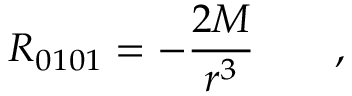Convert formula to latex. <formula><loc_0><loc_0><loc_500><loc_500>R _ { 0 1 0 1 } = - \frac { 2 M } { r ^ { 3 } } \quad ,</formula> 